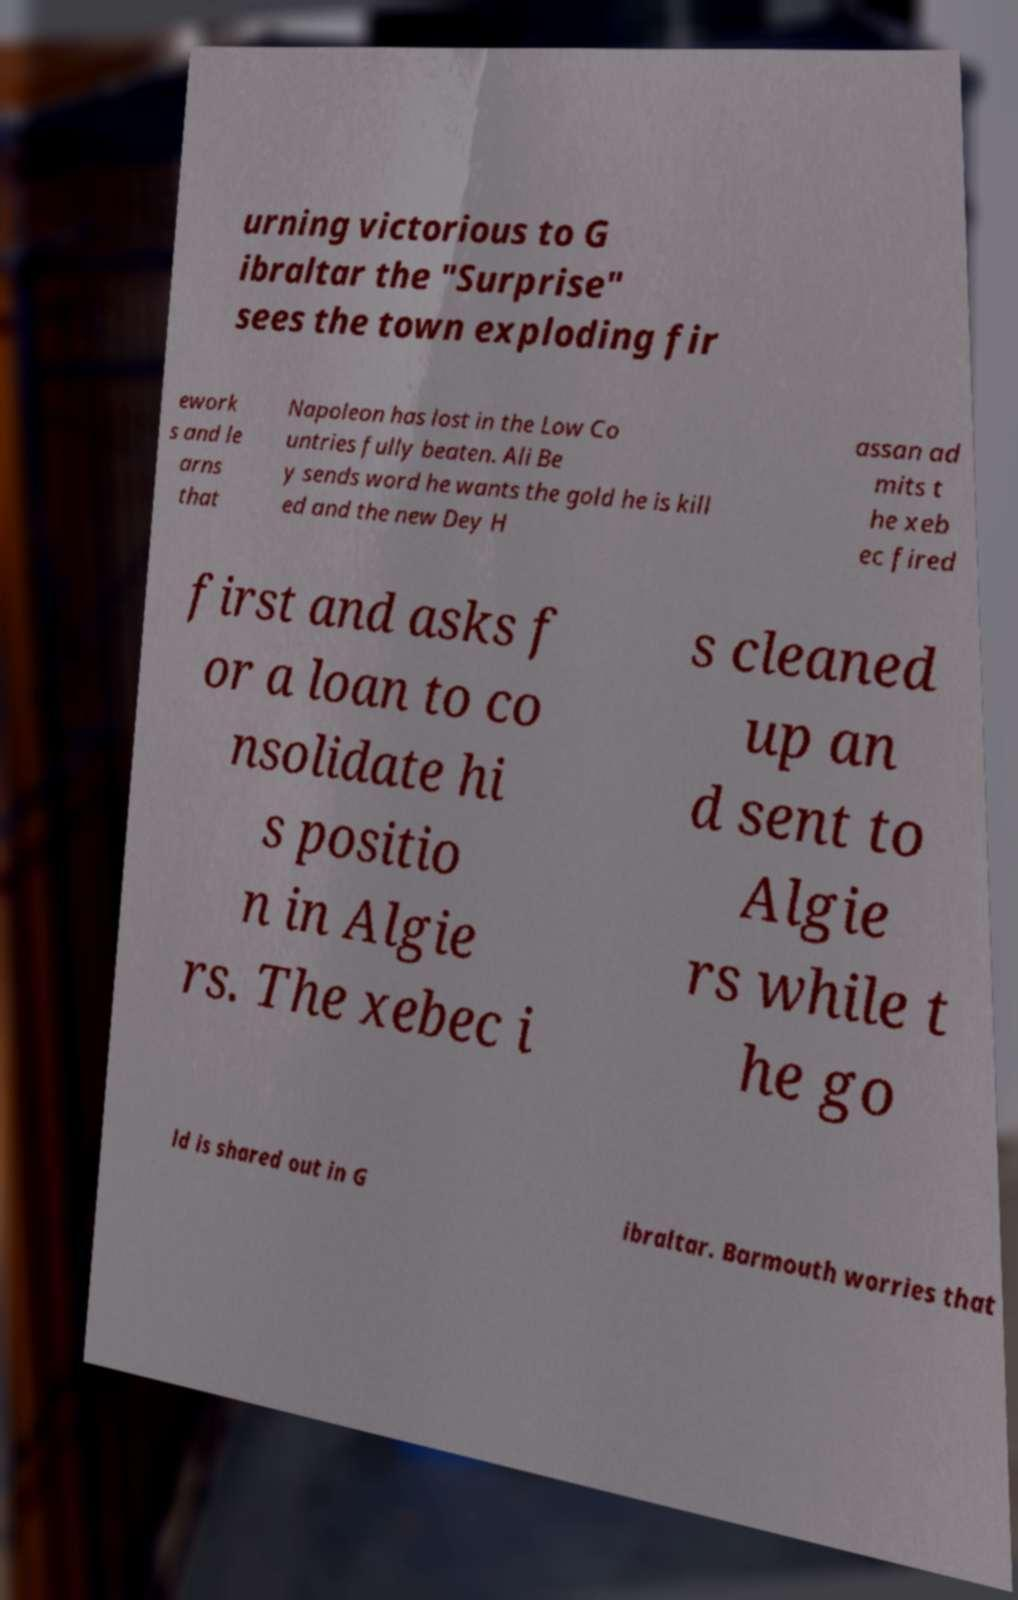Can you accurately transcribe the text from the provided image for me? urning victorious to G ibraltar the "Surprise" sees the town exploding fir ework s and le arns that Napoleon has lost in the Low Co untries fully beaten. Ali Be y sends word he wants the gold he is kill ed and the new Dey H assan ad mits t he xeb ec fired first and asks f or a loan to co nsolidate hi s positio n in Algie rs. The xebec i s cleaned up an d sent to Algie rs while t he go ld is shared out in G ibraltar. Barmouth worries that 